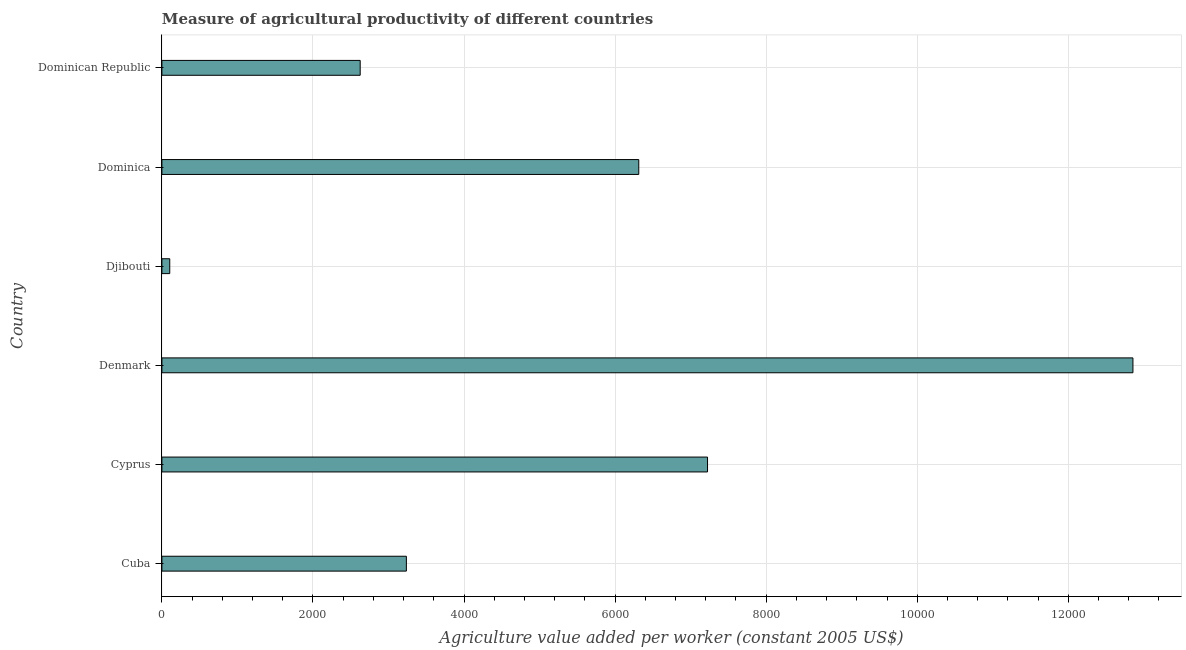Does the graph contain any zero values?
Provide a succinct answer. No. Does the graph contain grids?
Make the answer very short. Yes. What is the title of the graph?
Keep it short and to the point. Measure of agricultural productivity of different countries. What is the label or title of the X-axis?
Keep it short and to the point. Agriculture value added per worker (constant 2005 US$). What is the label or title of the Y-axis?
Make the answer very short. Country. What is the agriculture value added per worker in Djibouti?
Your answer should be compact. 103.98. Across all countries, what is the maximum agriculture value added per worker?
Give a very brief answer. 1.29e+04. Across all countries, what is the minimum agriculture value added per worker?
Give a very brief answer. 103.98. In which country was the agriculture value added per worker minimum?
Make the answer very short. Djibouti. What is the sum of the agriculture value added per worker?
Make the answer very short. 3.24e+04. What is the difference between the agriculture value added per worker in Denmark and Dominican Republic?
Ensure brevity in your answer.  1.02e+04. What is the average agriculture value added per worker per country?
Make the answer very short. 5393.24. What is the median agriculture value added per worker?
Your answer should be very brief. 4775.12. What is the ratio of the agriculture value added per worker in Djibouti to that in Dominica?
Make the answer very short. 0.02. Is the agriculture value added per worker in Cuba less than that in Cyprus?
Your response must be concise. Yes. What is the difference between the highest and the second highest agriculture value added per worker?
Offer a terse response. 5632.08. What is the difference between the highest and the lowest agriculture value added per worker?
Make the answer very short. 1.28e+04. Are all the bars in the graph horizontal?
Offer a very short reply. Yes. How many countries are there in the graph?
Keep it short and to the point. 6. What is the difference between two consecutive major ticks on the X-axis?
Keep it short and to the point. 2000. Are the values on the major ticks of X-axis written in scientific E-notation?
Give a very brief answer. No. What is the Agriculture value added per worker (constant 2005 US$) in Cuba?
Offer a terse response. 3236.79. What is the Agriculture value added per worker (constant 2005 US$) in Cyprus?
Keep it short and to the point. 7223.94. What is the Agriculture value added per worker (constant 2005 US$) in Denmark?
Ensure brevity in your answer.  1.29e+04. What is the Agriculture value added per worker (constant 2005 US$) of Djibouti?
Give a very brief answer. 103.98. What is the Agriculture value added per worker (constant 2005 US$) of Dominica?
Offer a terse response. 6313.45. What is the Agriculture value added per worker (constant 2005 US$) in Dominican Republic?
Provide a succinct answer. 2625.24. What is the difference between the Agriculture value added per worker (constant 2005 US$) in Cuba and Cyprus?
Your answer should be compact. -3987.15. What is the difference between the Agriculture value added per worker (constant 2005 US$) in Cuba and Denmark?
Give a very brief answer. -9619.23. What is the difference between the Agriculture value added per worker (constant 2005 US$) in Cuba and Djibouti?
Your answer should be very brief. 3132.8. What is the difference between the Agriculture value added per worker (constant 2005 US$) in Cuba and Dominica?
Your answer should be compact. -3076.67. What is the difference between the Agriculture value added per worker (constant 2005 US$) in Cuba and Dominican Republic?
Provide a succinct answer. 611.55. What is the difference between the Agriculture value added per worker (constant 2005 US$) in Cyprus and Denmark?
Your answer should be very brief. -5632.08. What is the difference between the Agriculture value added per worker (constant 2005 US$) in Cyprus and Djibouti?
Your answer should be very brief. 7119.96. What is the difference between the Agriculture value added per worker (constant 2005 US$) in Cyprus and Dominica?
Your response must be concise. 910.49. What is the difference between the Agriculture value added per worker (constant 2005 US$) in Cyprus and Dominican Republic?
Your answer should be very brief. 4598.7. What is the difference between the Agriculture value added per worker (constant 2005 US$) in Denmark and Djibouti?
Make the answer very short. 1.28e+04. What is the difference between the Agriculture value added per worker (constant 2005 US$) in Denmark and Dominica?
Give a very brief answer. 6542.57. What is the difference between the Agriculture value added per worker (constant 2005 US$) in Denmark and Dominican Republic?
Offer a very short reply. 1.02e+04. What is the difference between the Agriculture value added per worker (constant 2005 US$) in Djibouti and Dominica?
Provide a short and direct response. -6209.47. What is the difference between the Agriculture value added per worker (constant 2005 US$) in Djibouti and Dominican Republic?
Make the answer very short. -2521.25. What is the difference between the Agriculture value added per worker (constant 2005 US$) in Dominica and Dominican Republic?
Give a very brief answer. 3688.21. What is the ratio of the Agriculture value added per worker (constant 2005 US$) in Cuba to that in Cyprus?
Offer a very short reply. 0.45. What is the ratio of the Agriculture value added per worker (constant 2005 US$) in Cuba to that in Denmark?
Offer a very short reply. 0.25. What is the ratio of the Agriculture value added per worker (constant 2005 US$) in Cuba to that in Djibouti?
Make the answer very short. 31.13. What is the ratio of the Agriculture value added per worker (constant 2005 US$) in Cuba to that in Dominica?
Your answer should be compact. 0.51. What is the ratio of the Agriculture value added per worker (constant 2005 US$) in Cuba to that in Dominican Republic?
Offer a terse response. 1.23. What is the ratio of the Agriculture value added per worker (constant 2005 US$) in Cyprus to that in Denmark?
Your answer should be compact. 0.56. What is the ratio of the Agriculture value added per worker (constant 2005 US$) in Cyprus to that in Djibouti?
Give a very brief answer. 69.47. What is the ratio of the Agriculture value added per worker (constant 2005 US$) in Cyprus to that in Dominica?
Offer a terse response. 1.14. What is the ratio of the Agriculture value added per worker (constant 2005 US$) in Cyprus to that in Dominican Republic?
Make the answer very short. 2.75. What is the ratio of the Agriculture value added per worker (constant 2005 US$) in Denmark to that in Djibouti?
Ensure brevity in your answer.  123.64. What is the ratio of the Agriculture value added per worker (constant 2005 US$) in Denmark to that in Dominica?
Keep it short and to the point. 2.04. What is the ratio of the Agriculture value added per worker (constant 2005 US$) in Denmark to that in Dominican Republic?
Provide a short and direct response. 4.9. What is the ratio of the Agriculture value added per worker (constant 2005 US$) in Djibouti to that in Dominica?
Provide a short and direct response. 0.02. What is the ratio of the Agriculture value added per worker (constant 2005 US$) in Djibouti to that in Dominican Republic?
Offer a terse response. 0.04. What is the ratio of the Agriculture value added per worker (constant 2005 US$) in Dominica to that in Dominican Republic?
Provide a short and direct response. 2.4. 